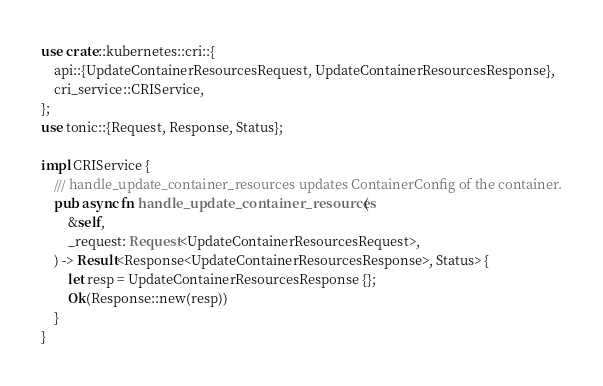<code> <loc_0><loc_0><loc_500><loc_500><_Rust_>use crate::kubernetes::cri::{
    api::{UpdateContainerResourcesRequest, UpdateContainerResourcesResponse},
    cri_service::CRIService,
};
use tonic::{Request, Response, Status};

impl CRIService {
    /// handle_update_container_resources updates ContainerConfig of the container.
    pub async fn handle_update_container_resources(
        &self,
        _request: Request<UpdateContainerResourcesRequest>,
    ) -> Result<Response<UpdateContainerResourcesResponse>, Status> {
        let resp = UpdateContainerResourcesResponse {};
        Ok(Response::new(resp))
    }
}
</code> 